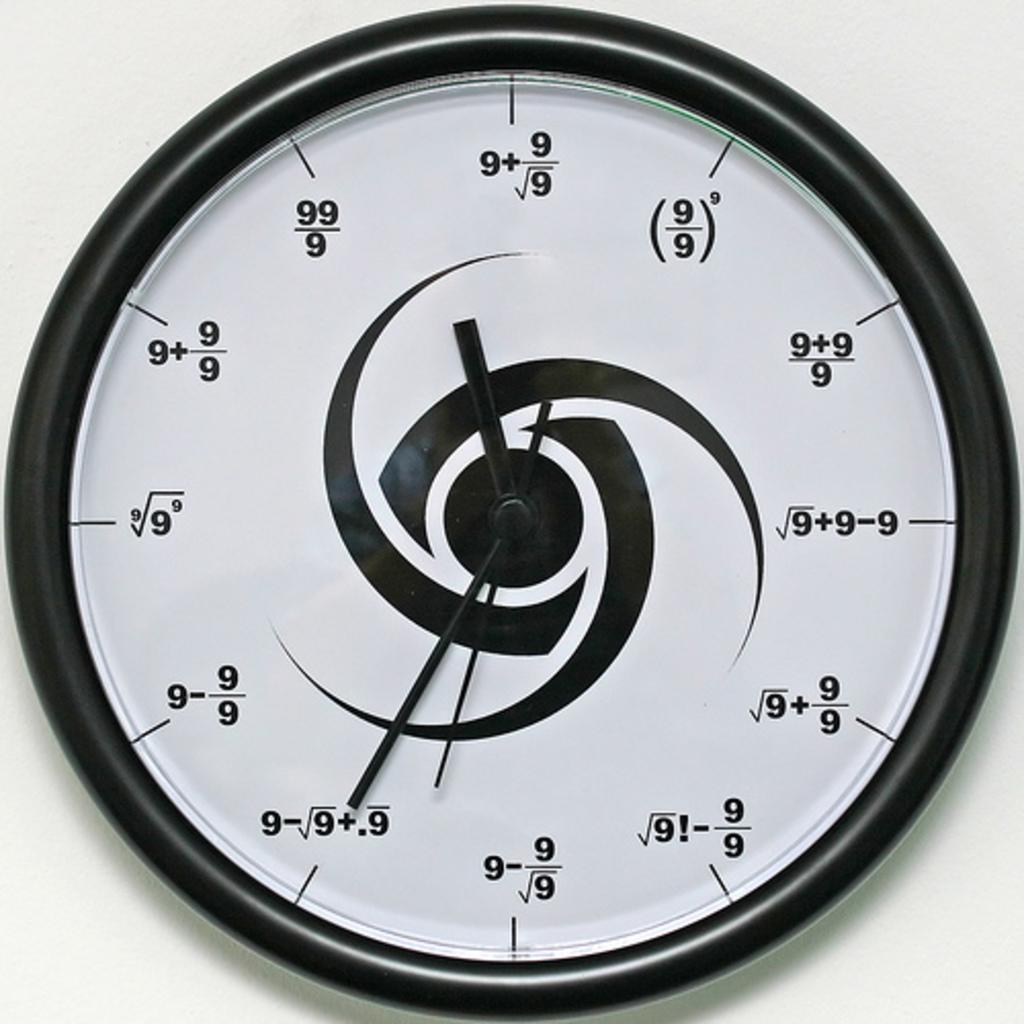What mathematics expression represents 1:00?
Your response must be concise. Unanswerable. Wht time is it?
Ensure brevity in your answer.  11:35. 